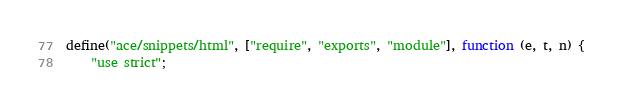<code> <loc_0><loc_0><loc_500><loc_500><_JavaScript_>define("ace/snippets/html", ["require", "exports", "module"], function (e, t, n) {
    "use strict";</code> 